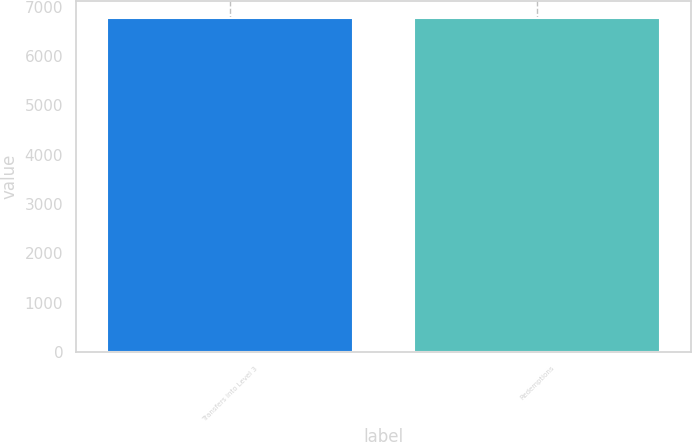<chart> <loc_0><loc_0><loc_500><loc_500><bar_chart><fcel>Transfers into Level 3<fcel>Redemptions<nl><fcel>6770<fcel>6770.1<nl></chart> 